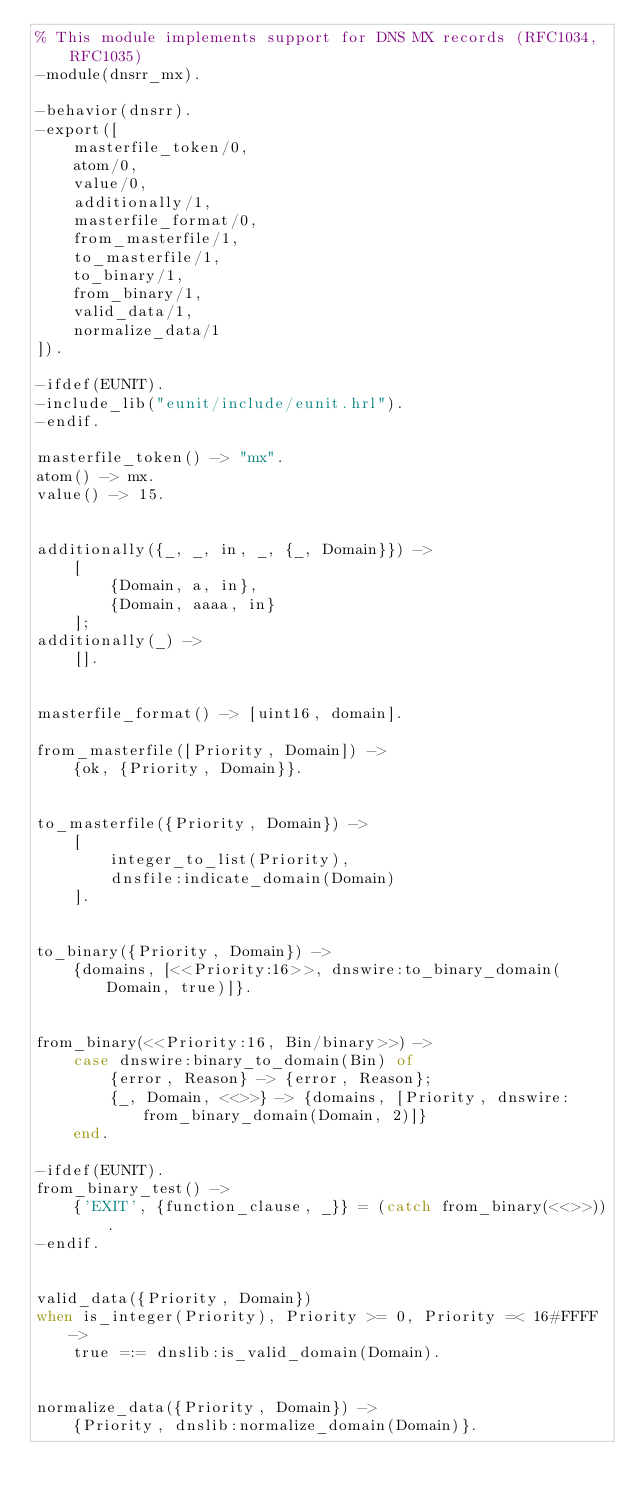Convert code to text. <code><loc_0><loc_0><loc_500><loc_500><_Erlang_>% This module implements support for DNS MX records (RFC1034, RFC1035)
-module(dnsrr_mx).

-behavior(dnsrr).
-export([
    masterfile_token/0,
    atom/0,
    value/0,
    additionally/1,
    masterfile_format/0,
    from_masterfile/1,
    to_masterfile/1,
    to_binary/1,
    from_binary/1,
    valid_data/1,
    normalize_data/1
]).

-ifdef(EUNIT).
-include_lib("eunit/include/eunit.hrl").
-endif.

masterfile_token() -> "mx".
atom() -> mx.
value() -> 15.


additionally({_, _, in, _, {_, Domain}}) ->
    [
        {Domain, a, in},
        {Domain, aaaa, in}
    ];
additionally(_) ->
    [].


masterfile_format() -> [uint16, domain].

from_masterfile([Priority, Domain]) ->
    {ok, {Priority, Domain}}.


to_masterfile({Priority, Domain}) ->
    [
        integer_to_list(Priority),
        dnsfile:indicate_domain(Domain)
    ].


to_binary({Priority, Domain}) ->
    {domains, [<<Priority:16>>, dnswire:to_binary_domain(Domain, true)]}.


from_binary(<<Priority:16, Bin/binary>>) ->
    case dnswire:binary_to_domain(Bin) of
        {error, Reason} -> {error, Reason};
        {_, Domain, <<>>} -> {domains, [Priority, dnswire:from_binary_domain(Domain, 2)]}
    end.

-ifdef(EUNIT).
from_binary_test() ->
    {'EXIT', {function_clause, _}} = (catch from_binary(<<>>)).
-endif.


valid_data({Priority, Domain})
when is_integer(Priority), Priority >= 0, Priority =< 16#FFFF ->
    true =:= dnslib:is_valid_domain(Domain).


normalize_data({Priority, Domain}) ->
    {Priority, dnslib:normalize_domain(Domain)}.
</code> 